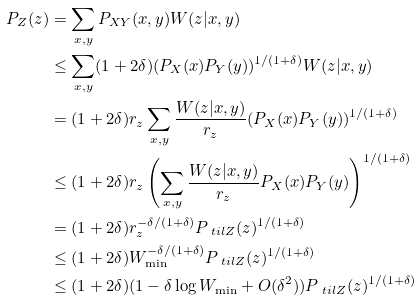<formula> <loc_0><loc_0><loc_500><loc_500>P _ { Z } ( z ) & = \sum _ { x , y } P _ { X Y } ( x , y ) W ( z | x , y ) \\ & \leq \sum _ { x , y } ( 1 + 2 \delta ) ( P _ { X } ( x ) P _ { Y } ( y ) ) ^ { 1 / ( 1 + \delta ) } W ( z | x , y ) \\ & = ( 1 + 2 \delta ) r _ { z } \sum _ { x , y } \frac { W ( z | x , y ) } { r _ { z } } ( P _ { X } ( x ) P _ { Y } ( y ) ) ^ { 1 / ( 1 + \delta ) } \\ & \leq ( 1 + 2 \delta ) r _ { z } \left ( \sum _ { x , y } \frac { W ( z | x , y ) } { r _ { z } } P _ { X } ( x ) P _ { Y } ( y ) \right ) ^ { 1 / ( 1 + \delta ) } \\ & = ( 1 + 2 \delta ) r _ { z } ^ { - \delta / ( 1 + \delta ) } P _ { \ t i l Z } ( z ) ^ { 1 / ( 1 + \delta ) } \\ & \leq ( 1 + 2 \delta ) W _ { \min } ^ { - \delta / ( 1 + \delta ) } P _ { \ t i l Z } ( z ) ^ { 1 / ( 1 + \delta ) } \\ & \leq ( 1 + 2 \delta ) ( 1 - \delta \log W _ { \min } + O ( \delta ^ { 2 } ) ) P _ { \ t i l Z } ( z ) ^ { 1 / ( 1 + \delta ) }</formula> 